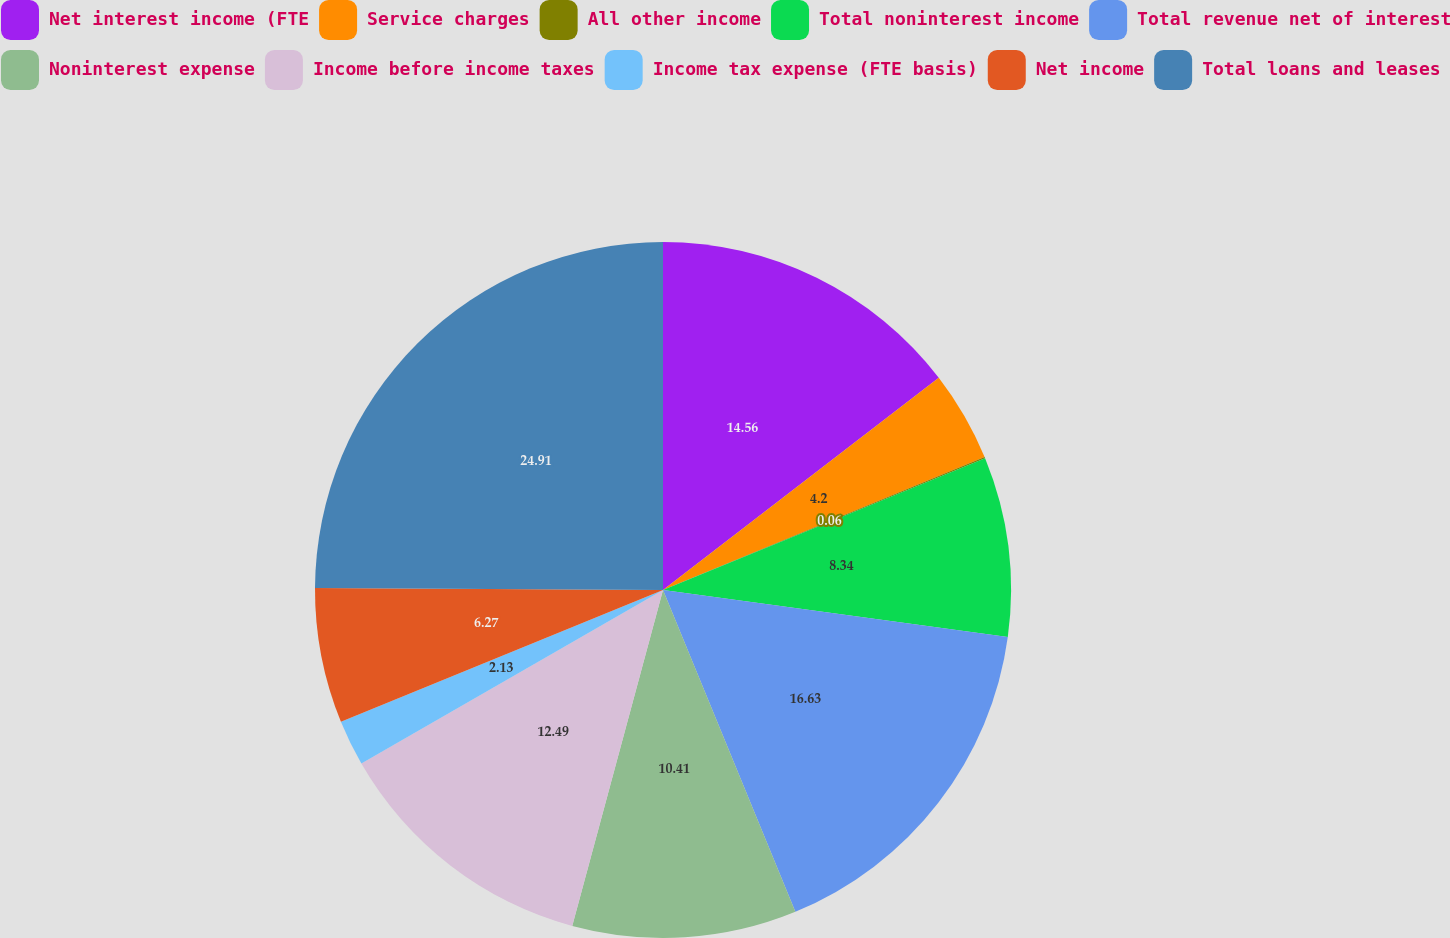Convert chart. <chart><loc_0><loc_0><loc_500><loc_500><pie_chart><fcel>Net interest income (FTE<fcel>Service charges<fcel>All other income<fcel>Total noninterest income<fcel>Total revenue net of interest<fcel>Noninterest expense<fcel>Income before income taxes<fcel>Income tax expense (FTE basis)<fcel>Net income<fcel>Total loans and leases<nl><fcel>14.56%<fcel>4.2%<fcel>0.06%<fcel>8.34%<fcel>16.63%<fcel>10.41%<fcel>12.49%<fcel>2.13%<fcel>6.27%<fcel>24.91%<nl></chart> 